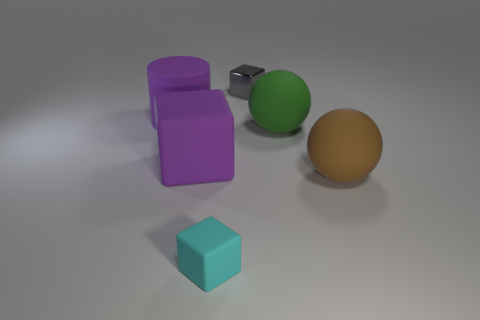Subtract all purple rubber cubes. How many cubes are left? 2 Subtract 1 blocks. How many blocks are left? 2 Add 2 large purple metal objects. How many objects exist? 8 Subtract all balls. How many objects are left? 4 Add 2 large purple rubber things. How many large purple rubber things are left? 4 Add 5 big gray metallic blocks. How many big gray metallic blocks exist? 5 Subtract 0 gray balls. How many objects are left? 6 Subtract all brown cylinders. Subtract all yellow blocks. How many cylinders are left? 1 Subtract all tiny green shiny things. Subtract all large purple matte cubes. How many objects are left? 5 